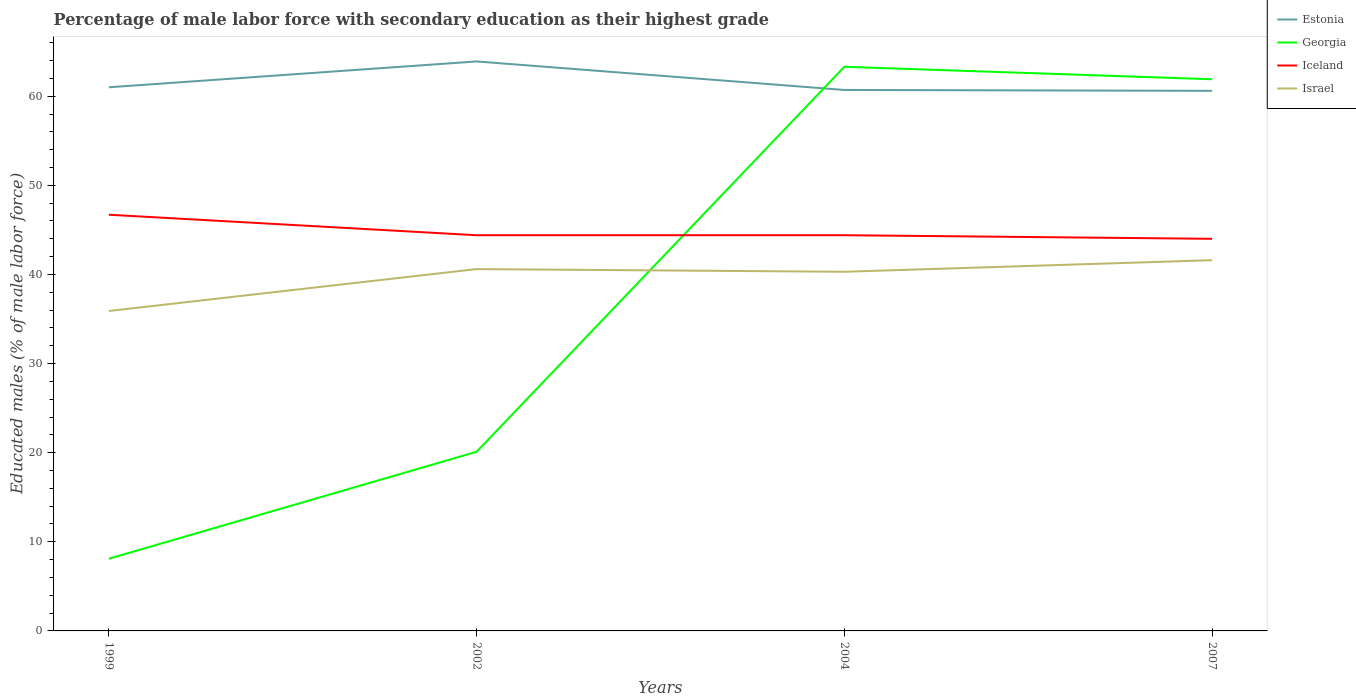Across all years, what is the maximum percentage of male labor force with secondary education in Georgia?
Your answer should be compact. 8.1. What is the total percentage of male labor force with secondary education in Estonia in the graph?
Your answer should be very brief. 0.3. What is the difference between the highest and the second highest percentage of male labor force with secondary education in Estonia?
Offer a terse response. 3.3. Is the percentage of male labor force with secondary education in Israel strictly greater than the percentage of male labor force with secondary education in Georgia over the years?
Your answer should be compact. No. How many years are there in the graph?
Keep it short and to the point. 4. What is the difference between two consecutive major ticks on the Y-axis?
Your answer should be very brief. 10. Does the graph contain grids?
Offer a terse response. No. Where does the legend appear in the graph?
Offer a very short reply. Top right. How many legend labels are there?
Provide a succinct answer. 4. What is the title of the graph?
Provide a short and direct response. Percentage of male labor force with secondary education as their highest grade. What is the label or title of the X-axis?
Make the answer very short. Years. What is the label or title of the Y-axis?
Your response must be concise. Educated males (% of male labor force). What is the Educated males (% of male labor force) of Estonia in 1999?
Give a very brief answer. 61. What is the Educated males (% of male labor force) of Georgia in 1999?
Make the answer very short. 8.1. What is the Educated males (% of male labor force) in Iceland in 1999?
Offer a terse response. 46.7. What is the Educated males (% of male labor force) of Israel in 1999?
Offer a terse response. 35.9. What is the Educated males (% of male labor force) in Estonia in 2002?
Ensure brevity in your answer.  63.9. What is the Educated males (% of male labor force) of Georgia in 2002?
Make the answer very short. 20.1. What is the Educated males (% of male labor force) of Iceland in 2002?
Your response must be concise. 44.4. What is the Educated males (% of male labor force) in Israel in 2002?
Your answer should be very brief. 40.6. What is the Educated males (% of male labor force) in Estonia in 2004?
Provide a short and direct response. 60.7. What is the Educated males (% of male labor force) in Georgia in 2004?
Your answer should be compact. 63.3. What is the Educated males (% of male labor force) in Iceland in 2004?
Provide a short and direct response. 44.4. What is the Educated males (% of male labor force) in Israel in 2004?
Offer a very short reply. 40.3. What is the Educated males (% of male labor force) in Estonia in 2007?
Your answer should be compact. 60.6. What is the Educated males (% of male labor force) in Georgia in 2007?
Offer a terse response. 61.9. What is the Educated males (% of male labor force) in Iceland in 2007?
Give a very brief answer. 44. What is the Educated males (% of male labor force) in Israel in 2007?
Give a very brief answer. 41.6. Across all years, what is the maximum Educated males (% of male labor force) in Estonia?
Your answer should be compact. 63.9. Across all years, what is the maximum Educated males (% of male labor force) in Georgia?
Your answer should be compact. 63.3. Across all years, what is the maximum Educated males (% of male labor force) in Iceland?
Your answer should be compact. 46.7. Across all years, what is the maximum Educated males (% of male labor force) in Israel?
Your answer should be compact. 41.6. Across all years, what is the minimum Educated males (% of male labor force) of Estonia?
Offer a terse response. 60.6. Across all years, what is the minimum Educated males (% of male labor force) in Georgia?
Offer a very short reply. 8.1. Across all years, what is the minimum Educated males (% of male labor force) in Israel?
Offer a very short reply. 35.9. What is the total Educated males (% of male labor force) in Estonia in the graph?
Your response must be concise. 246.2. What is the total Educated males (% of male labor force) of Georgia in the graph?
Provide a short and direct response. 153.4. What is the total Educated males (% of male labor force) in Iceland in the graph?
Provide a succinct answer. 179.5. What is the total Educated males (% of male labor force) of Israel in the graph?
Your answer should be compact. 158.4. What is the difference between the Educated males (% of male labor force) of Georgia in 1999 and that in 2002?
Keep it short and to the point. -12. What is the difference between the Educated males (% of male labor force) of Estonia in 1999 and that in 2004?
Make the answer very short. 0.3. What is the difference between the Educated males (% of male labor force) of Georgia in 1999 and that in 2004?
Provide a succinct answer. -55.2. What is the difference between the Educated males (% of male labor force) of Iceland in 1999 and that in 2004?
Keep it short and to the point. 2.3. What is the difference between the Educated males (% of male labor force) of Israel in 1999 and that in 2004?
Provide a short and direct response. -4.4. What is the difference between the Educated males (% of male labor force) in Georgia in 1999 and that in 2007?
Make the answer very short. -53.8. What is the difference between the Educated males (% of male labor force) in Israel in 1999 and that in 2007?
Your answer should be compact. -5.7. What is the difference between the Educated males (% of male labor force) in Georgia in 2002 and that in 2004?
Make the answer very short. -43.2. What is the difference between the Educated males (% of male labor force) in Estonia in 2002 and that in 2007?
Offer a very short reply. 3.3. What is the difference between the Educated males (% of male labor force) in Georgia in 2002 and that in 2007?
Make the answer very short. -41.8. What is the difference between the Educated males (% of male labor force) of Iceland in 2002 and that in 2007?
Your answer should be very brief. 0.4. What is the difference between the Educated males (% of male labor force) of Estonia in 2004 and that in 2007?
Keep it short and to the point. 0.1. What is the difference between the Educated males (% of male labor force) in Iceland in 2004 and that in 2007?
Offer a very short reply. 0.4. What is the difference between the Educated males (% of male labor force) in Estonia in 1999 and the Educated males (% of male labor force) in Georgia in 2002?
Offer a terse response. 40.9. What is the difference between the Educated males (% of male labor force) in Estonia in 1999 and the Educated males (% of male labor force) in Iceland in 2002?
Your answer should be compact. 16.6. What is the difference between the Educated males (% of male labor force) of Estonia in 1999 and the Educated males (% of male labor force) of Israel in 2002?
Keep it short and to the point. 20.4. What is the difference between the Educated males (% of male labor force) of Georgia in 1999 and the Educated males (% of male labor force) of Iceland in 2002?
Offer a very short reply. -36.3. What is the difference between the Educated males (% of male labor force) in Georgia in 1999 and the Educated males (% of male labor force) in Israel in 2002?
Offer a very short reply. -32.5. What is the difference between the Educated males (% of male labor force) of Iceland in 1999 and the Educated males (% of male labor force) of Israel in 2002?
Your answer should be compact. 6.1. What is the difference between the Educated males (% of male labor force) of Estonia in 1999 and the Educated males (% of male labor force) of Georgia in 2004?
Keep it short and to the point. -2.3. What is the difference between the Educated males (% of male labor force) of Estonia in 1999 and the Educated males (% of male labor force) of Iceland in 2004?
Make the answer very short. 16.6. What is the difference between the Educated males (% of male labor force) in Estonia in 1999 and the Educated males (% of male labor force) in Israel in 2004?
Keep it short and to the point. 20.7. What is the difference between the Educated males (% of male labor force) in Georgia in 1999 and the Educated males (% of male labor force) in Iceland in 2004?
Provide a succinct answer. -36.3. What is the difference between the Educated males (% of male labor force) in Georgia in 1999 and the Educated males (% of male labor force) in Israel in 2004?
Ensure brevity in your answer.  -32.2. What is the difference between the Educated males (% of male labor force) of Iceland in 1999 and the Educated males (% of male labor force) of Israel in 2004?
Give a very brief answer. 6.4. What is the difference between the Educated males (% of male labor force) of Estonia in 1999 and the Educated males (% of male labor force) of Iceland in 2007?
Give a very brief answer. 17. What is the difference between the Educated males (% of male labor force) of Estonia in 1999 and the Educated males (% of male labor force) of Israel in 2007?
Provide a short and direct response. 19.4. What is the difference between the Educated males (% of male labor force) in Georgia in 1999 and the Educated males (% of male labor force) in Iceland in 2007?
Your answer should be very brief. -35.9. What is the difference between the Educated males (% of male labor force) of Georgia in 1999 and the Educated males (% of male labor force) of Israel in 2007?
Your answer should be very brief. -33.5. What is the difference between the Educated males (% of male labor force) in Estonia in 2002 and the Educated males (% of male labor force) in Georgia in 2004?
Provide a succinct answer. 0.6. What is the difference between the Educated males (% of male labor force) of Estonia in 2002 and the Educated males (% of male labor force) of Iceland in 2004?
Offer a very short reply. 19.5. What is the difference between the Educated males (% of male labor force) in Estonia in 2002 and the Educated males (% of male labor force) in Israel in 2004?
Your response must be concise. 23.6. What is the difference between the Educated males (% of male labor force) of Georgia in 2002 and the Educated males (% of male labor force) of Iceland in 2004?
Provide a short and direct response. -24.3. What is the difference between the Educated males (% of male labor force) in Georgia in 2002 and the Educated males (% of male labor force) in Israel in 2004?
Your answer should be compact. -20.2. What is the difference between the Educated males (% of male labor force) in Estonia in 2002 and the Educated males (% of male labor force) in Georgia in 2007?
Offer a very short reply. 2. What is the difference between the Educated males (% of male labor force) of Estonia in 2002 and the Educated males (% of male labor force) of Israel in 2007?
Offer a very short reply. 22.3. What is the difference between the Educated males (% of male labor force) of Georgia in 2002 and the Educated males (% of male labor force) of Iceland in 2007?
Ensure brevity in your answer.  -23.9. What is the difference between the Educated males (% of male labor force) in Georgia in 2002 and the Educated males (% of male labor force) in Israel in 2007?
Your answer should be compact. -21.5. What is the difference between the Educated males (% of male labor force) in Estonia in 2004 and the Educated males (% of male labor force) in Georgia in 2007?
Your answer should be compact. -1.2. What is the difference between the Educated males (% of male labor force) of Estonia in 2004 and the Educated males (% of male labor force) of Israel in 2007?
Provide a succinct answer. 19.1. What is the difference between the Educated males (% of male labor force) of Georgia in 2004 and the Educated males (% of male labor force) of Iceland in 2007?
Provide a short and direct response. 19.3. What is the difference between the Educated males (% of male labor force) of Georgia in 2004 and the Educated males (% of male labor force) of Israel in 2007?
Your answer should be very brief. 21.7. What is the difference between the Educated males (% of male labor force) in Iceland in 2004 and the Educated males (% of male labor force) in Israel in 2007?
Keep it short and to the point. 2.8. What is the average Educated males (% of male labor force) in Estonia per year?
Give a very brief answer. 61.55. What is the average Educated males (% of male labor force) in Georgia per year?
Your response must be concise. 38.35. What is the average Educated males (% of male labor force) in Iceland per year?
Give a very brief answer. 44.88. What is the average Educated males (% of male labor force) in Israel per year?
Make the answer very short. 39.6. In the year 1999, what is the difference between the Educated males (% of male labor force) of Estonia and Educated males (% of male labor force) of Georgia?
Give a very brief answer. 52.9. In the year 1999, what is the difference between the Educated males (% of male labor force) of Estonia and Educated males (% of male labor force) of Israel?
Ensure brevity in your answer.  25.1. In the year 1999, what is the difference between the Educated males (% of male labor force) in Georgia and Educated males (% of male labor force) in Iceland?
Give a very brief answer. -38.6. In the year 1999, what is the difference between the Educated males (% of male labor force) in Georgia and Educated males (% of male labor force) in Israel?
Make the answer very short. -27.8. In the year 2002, what is the difference between the Educated males (% of male labor force) of Estonia and Educated males (% of male labor force) of Georgia?
Give a very brief answer. 43.8. In the year 2002, what is the difference between the Educated males (% of male labor force) in Estonia and Educated males (% of male labor force) in Israel?
Make the answer very short. 23.3. In the year 2002, what is the difference between the Educated males (% of male labor force) of Georgia and Educated males (% of male labor force) of Iceland?
Make the answer very short. -24.3. In the year 2002, what is the difference between the Educated males (% of male labor force) of Georgia and Educated males (% of male labor force) of Israel?
Provide a succinct answer. -20.5. In the year 2004, what is the difference between the Educated males (% of male labor force) of Estonia and Educated males (% of male labor force) of Israel?
Offer a terse response. 20.4. In the year 2004, what is the difference between the Educated males (% of male labor force) in Georgia and Educated males (% of male labor force) in Iceland?
Keep it short and to the point. 18.9. In the year 2004, what is the difference between the Educated males (% of male labor force) of Georgia and Educated males (% of male labor force) of Israel?
Your answer should be very brief. 23. In the year 2007, what is the difference between the Educated males (% of male labor force) in Estonia and Educated males (% of male labor force) in Georgia?
Your response must be concise. -1.3. In the year 2007, what is the difference between the Educated males (% of male labor force) of Estonia and Educated males (% of male labor force) of Iceland?
Keep it short and to the point. 16.6. In the year 2007, what is the difference between the Educated males (% of male labor force) of Estonia and Educated males (% of male labor force) of Israel?
Keep it short and to the point. 19. In the year 2007, what is the difference between the Educated males (% of male labor force) in Georgia and Educated males (% of male labor force) in Israel?
Your response must be concise. 20.3. What is the ratio of the Educated males (% of male labor force) of Estonia in 1999 to that in 2002?
Ensure brevity in your answer.  0.95. What is the ratio of the Educated males (% of male labor force) of Georgia in 1999 to that in 2002?
Keep it short and to the point. 0.4. What is the ratio of the Educated males (% of male labor force) in Iceland in 1999 to that in 2002?
Provide a succinct answer. 1.05. What is the ratio of the Educated males (% of male labor force) in Israel in 1999 to that in 2002?
Make the answer very short. 0.88. What is the ratio of the Educated males (% of male labor force) of Georgia in 1999 to that in 2004?
Provide a short and direct response. 0.13. What is the ratio of the Educated males (% of male labor force) of Iceland in 1999 to that in 2004?
Your response must be concise. 1.05. What is the ratio of the Educated males (% of male labor force) of Israel in 1999 to that in 2004?
Provide a short and direct response. 0.89. What is the ratio of the Educated males (% of male labor force) in Estonia in 1999 to that in 2007?
Give a very brief answer. 1.01. What is the ratio of the Educated males (% of male labor force) of Georgia in 1999 to that in 2007?
Offer a very short reply. 0.13. What is the ratio of the Educated males (% of male labor force) of Iceland in 1999 to that in 2007?
Your response must be concise. 1.06. What is the ratio of the Educated males (% of male labor force) in Israel in 1999 to that in 2007?
Keep it short and to the point. 0.86. What is the ratio of the Educated males (% of male labor force) in Estonia in 2002 to that in 2004?
Offer a very short reply. 1.05. What is the ratio of the Educated males (% of male labor force) of Georgia in 2002 to that in 2004?
Your response must be concise. 0.32. What is the ratio of the Educated males (% of male labor force) of Israel in 2002 to that in 2004?
Give a very brief answer. 1.01. What is the ratio of the Educated males (% of male labor force) in Estonia in 2002 to that in 2007?
Your answer should be compact. 1.05. What is the ratio of the Educated males (% of male labor force) of Georgia in 2002 to that in 2007?
Offer a terse response. 0.32. What is the ratio of the Educated males (% of male labor force) of Iceland in 2002 to that in 2007?
Your response must be concise. 1.01. What is the ratio of the Educated males (% of male labor force) of Georgia in 2004 to that in 2007?
Provide a succinct answer. 1.02. What is the ratio of the Educated males (% of male labor force) in Iceland in 2004 to that in 2007?
Ensure brevity in your answer.  1.01. What is the ratio of the Educated males (% of male labor force) of Israel in 2004 to that in 2007?
Make the answer very short. 0.97. What is the difference between the highest and the second highest Educated males (% of male labor force) of Estonia?
Ensure brevity in your answer.  2.9. What is the difference between the highest and the second highest Educated males (% of male labor force) in Georgia?
Keep it short and to the point. 1.4. What is the difference between the highest and the second highest Educated males (% of male labor force) in Israel?
Your answer should be very brief. 1. What is the difference between the highest and the lowest Educated males (% of male labor force) in Estonia?
Make the answer very short. 3.3. What is the difference between the highest and the lowest Educated males (% of male labor force) in Georgia?
Your response must be concise. 55.2. What is the difference between the highest and the lowest Educated males (% of male labor force) in Iceland?
Your response must be concise. 2.7. What is the difference between the highest and the lowest Educated males (% of male labor force) of Israel?
Your answer should be compact. 5.7. 